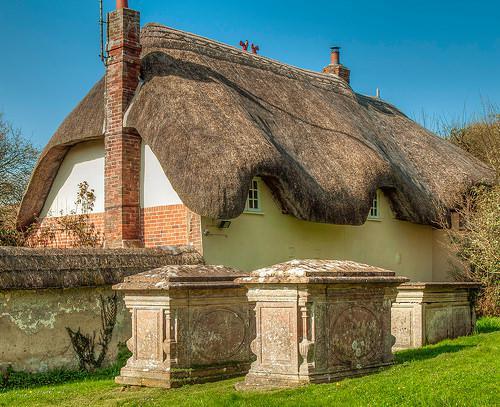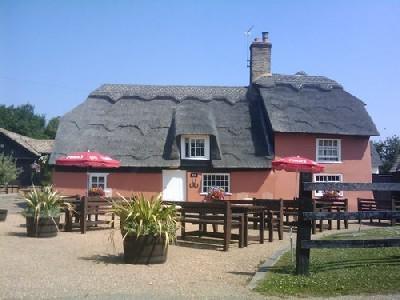The first image is the image on the left, the second image is the image on the right. Examine the images to the left and right. Is the description "The left image shows potted plants on a grassless surface in front of an orangish building with a curving 'cap' along the peak of the roof and a notch to accommodate a window." accurate? Answer yes or no. No. 